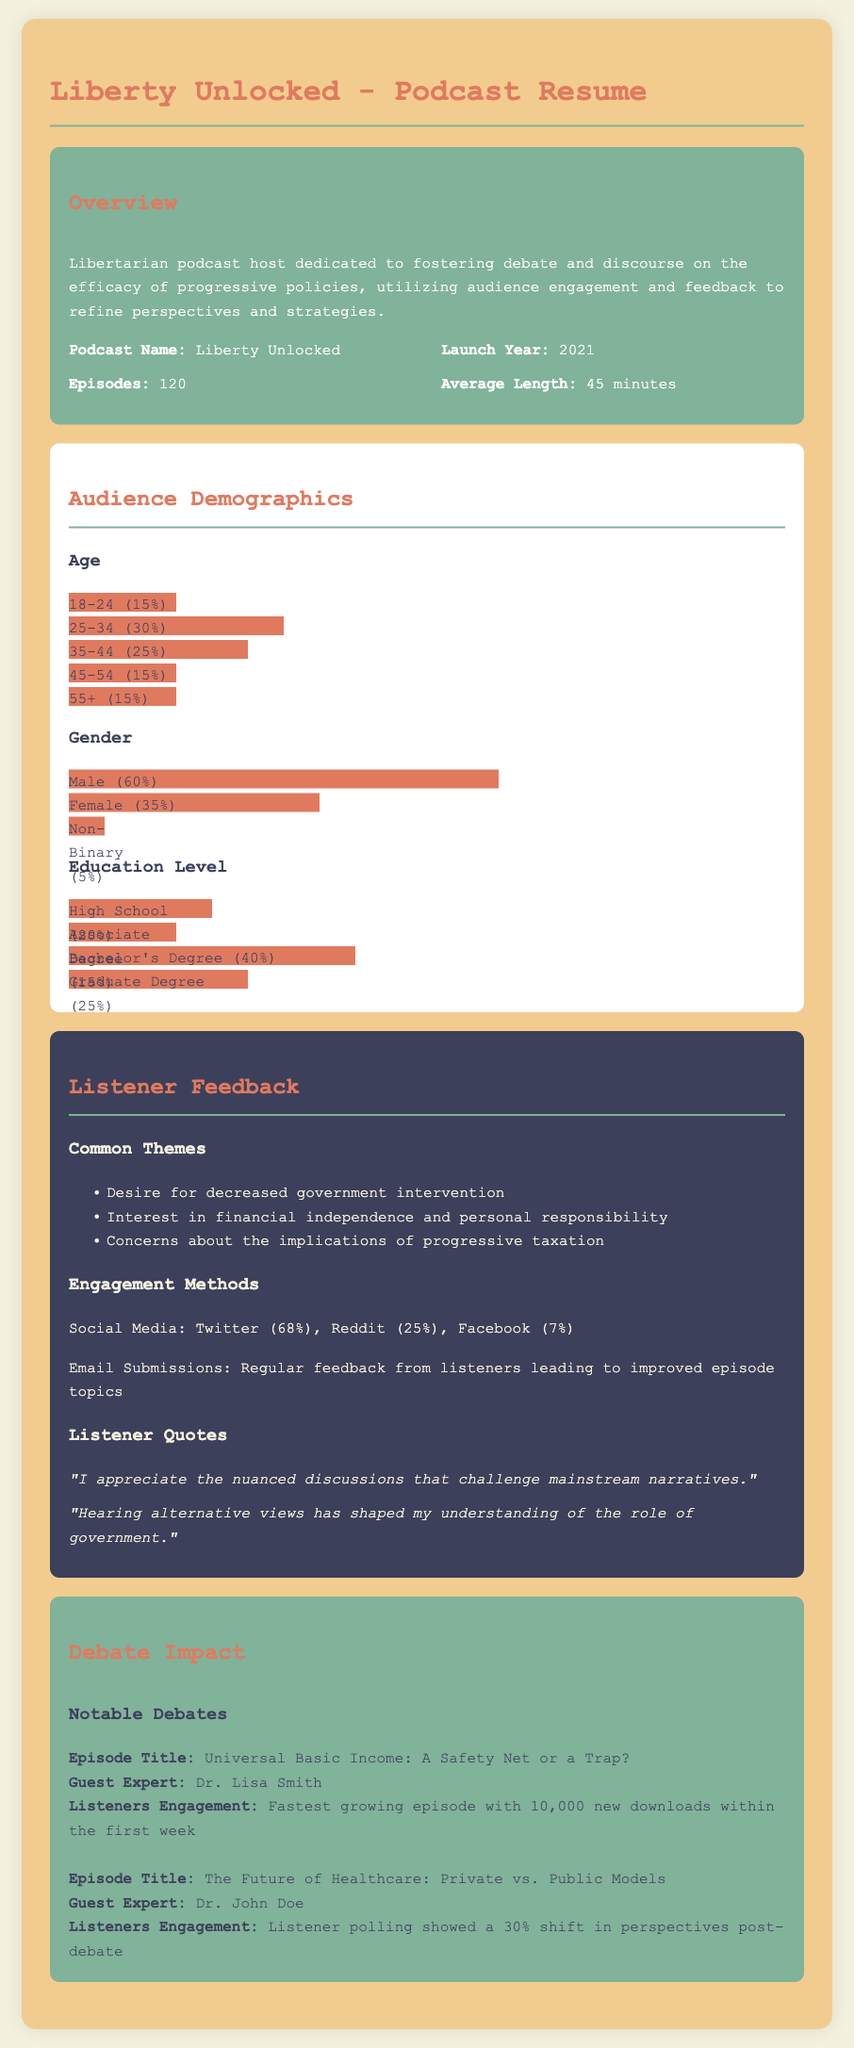what is the podcast name? The podcast name is mentioned in the overview section of the document.
Answer: Liberty Unlocked when was the podcast launched? The launch year of the podcast is specified in the overview section.
Answer: 2021 how many episodes does the podcast have? The total number of episodes is provided in the overview section.
Answer: 120 what percentage of listeners is male? The gender demographics indicate the percentage of male listeners.
Answer: 60% what are the top social media platforms for engagement? The engagement methods section lists the platforms and their percentages.
Answer: Twitter (68%) what is the theme of the listener feedback? Common listener feedback themes are detailed in the feedback section.
Answer: Decreased government intervention which episode had the fastest growth in downloads? The notable debates section mentions the episode with the highest downloads.
Answer: Universal Basic Income: A Safety Net or a Trap? what shift in perspectives was noted after a specific debate? Listener polling results after a particular debate are provided in the document.
Answer: 30% shift who was the guest expert in the healthcare debate episode? The notable debates section lists the guest expert for that episode.
Answer: Dr. John Doe 